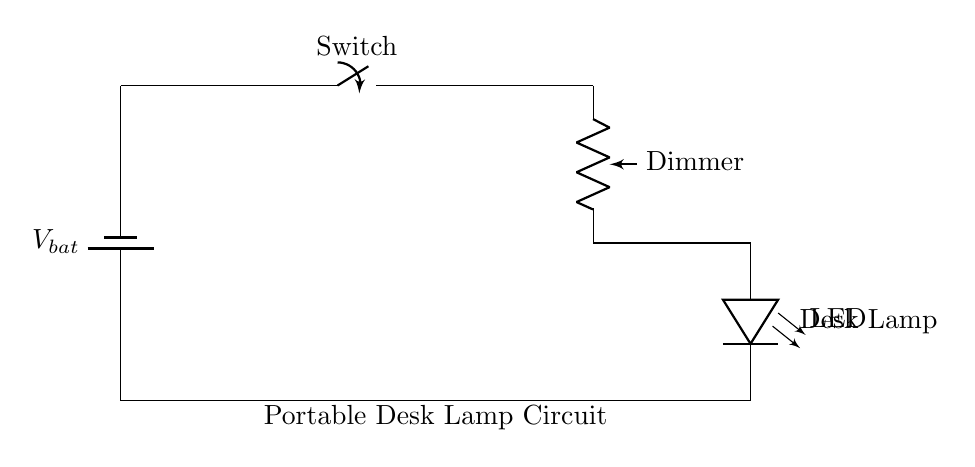What components are present in this circuit? The circuit contains a battery, switch, potentiometer, and an LED. Each component is indicated clearly in the schematic, showing their function within the circuit as part of the portable desk lamp.
Answer: battery, switch, potentiometer, LED What is the function of the switch in this circuit? The switch controls the flow of current, allowing the user to turn the lamp on or off. When the switch is closed, current flows; when it's open, the circuit is broken, and the lamp does not illuminate.
Answer: controls current flow What does the dimmer adjust in this circuit? The dimmer, represented as a potentiometer, adjusts the brightness of the LED by changing the resistance. By varying the resistance, it alters the current flowing to the LED, thus controlling its brightness.
Answer: LED brightness How do you complete the circuit? The circuit is completed by connecting the LED back to the negative terminal of the battery, creating a loop for the current to flow. This ensures that the current can continually circulate as long as the switch is closed.
Answer: Connecting LED to battery What happens if the dimmer is set to the highest resistance? If the dimmer is set to the highest resistance, less current flows to the LED, causing it to be dim or possibly turn off, depending on the LED's voltage requirements. The potentiometer effectively limits the amount of electrical energy reaching the LED.
Answer: LED dims or turns off Is this circuit designed for alternating current or direct current? This circuit is designed for direct current, as indicated by the presence of a battery as the power source, which provides a constant electrical flow in one direction, necessary for the operation of the LED.
Answer: direct current 